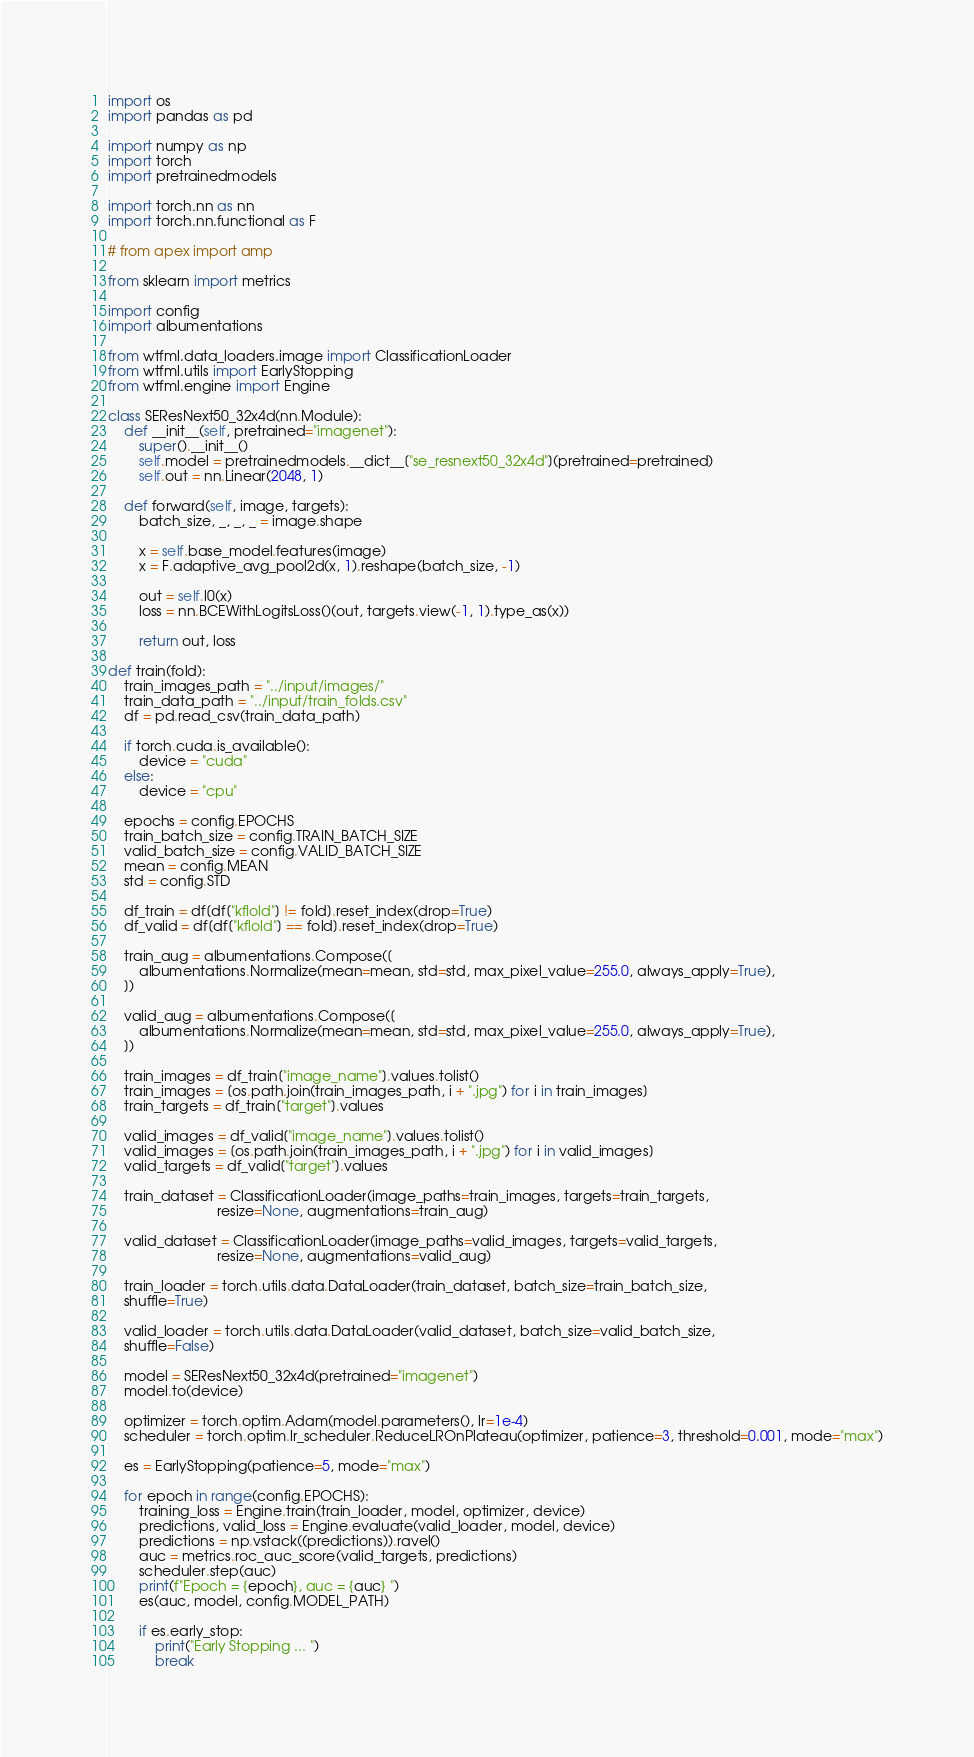Convert code to text. <code><loc_0><loc_0><loc_500><loc_500><_Python_>import os
import pandas as pd

import numpy as np
import torch
import pretrainedmodels

import torch.nn as nn
import torch.nn.functional as F

# from apex import amp

from sklearn import metrics

import config
import albumentations

from wtfml.data_loaders.image import ClassificationLoader
from wtfml.utils import EarlyStopping
from wtfml.engine import Engine

class SEResNext50_32x4d(nn.Module):
    def __init__(self, pretrained="imagenet"):
        super().__init__()
        self.model = pretrainedmodels.__dict__["se_resnext50_32x4d"](pretrained=pretrained)
        self.out = nn.Linear(2048, 1)
    
    def forward(self, image, targets):
        batch_size, _, _, _ = image.shape
        
        x = self.base_model.features(image)
        x = F.adaptive_avg_pool2d(x, 1).reshape(batch_size, -1)
        
        out = self.l0(x)
        loss = nn.BCEWithLogitsLoss()(out, targets.view(-1, 1).type_as(x))

        return out, loss

def train(fold):
    train_images_path = "../input/images/"
    train_data_path = "../input/train_folds.csv"
    df = pd.read_csv(train_data_path)
    
    if torch.cuda.is_available():
        device = "cuda"
    else:
        device = "cpu"
    
    epochs = config.EPOCHS
    train_batch_size = config.TRAIN_BATCH_SIZE
    valid_batch_size = config.VALID_BATCH_SIZE
    mean = config.MEAN
    std = config.STD

    df_train = df[df["kflold"] != fold].reset_index(drop=True)
    df_valid = df[df["kflold"] == fold].reset_index(drop=True)

    train_aug = albumentations.Compose([
        albumentations.Normalize(mean=mean, std=std, max_pixel_value=255.0, always_apply=True),
    ])

    valid_aug = albumentations.Compose([
        albumentations.Normalize(mean=mean, std=std, max_pixel_value=255.0, always_apply=True),
    ])

    train_images = df_train["image_name"].values.tolist()
    train_images = [os.path.join(train_images_path, i + ".jpg") for i in train_images]
    train_targets = df_train["target"].values

    valid_images = df_valid["image_name"].values.tolist()
    valid_images = [os.path.join(train_images_path, i + ".jpg") for i in valid_images]
    valid_targets = df_valid["target"].values
    
    train_dataset = ClassificationLoader(image_paths=train_images, targets=train_targets, 
                            resize=None, augmentations=train_aug)
    
    valid_dataset = ClassificationLoader(image_paths=valid_images, targets=valid_targets, 
                            resize=None, augmentations=valid_aug)
    
    train_loader = torch.utils.data.DataLoader(train_dataset, batch_size=train_batch_size,
    shuffle=True)

    valid_loader = torch.utils.data.DataLoader(valid_dataset, batch_size=valid_batch_size,
    shuffle=False)

    model = SEResNext50_32x4d(pretrained="imagenet")
    model.to(device)

    optimizer = torch.optim.Adam(model.parameters(), lr=1e-4)
    scheduler = torch.optim.lr_scheduler.ReduceLROnPlateau(optimizer, patience=3, threshold=0.001, mode="max")

    es = EarlyStopping(patience=5, mode="max")

    for epoch in range(config.EPOCHS):
        training_loss = Engine.train(train_loader, model, optimizer, device)
        predictions, valid_loss = Engine.evaluate(valid_loader, model, device)
        predictions = np.vstack((predictions)).ravel()
        auc = metrics.roc_auc_score(valid_targets, predictions)
        scheduler.step(auc)
        print(f"Epoch = {epoch}, auc = {auc} ")
        es(auc, model, config.MODEL_PATH)

        if es.early_stop:
            print("Early Stopping ... ")
            break
</code> 